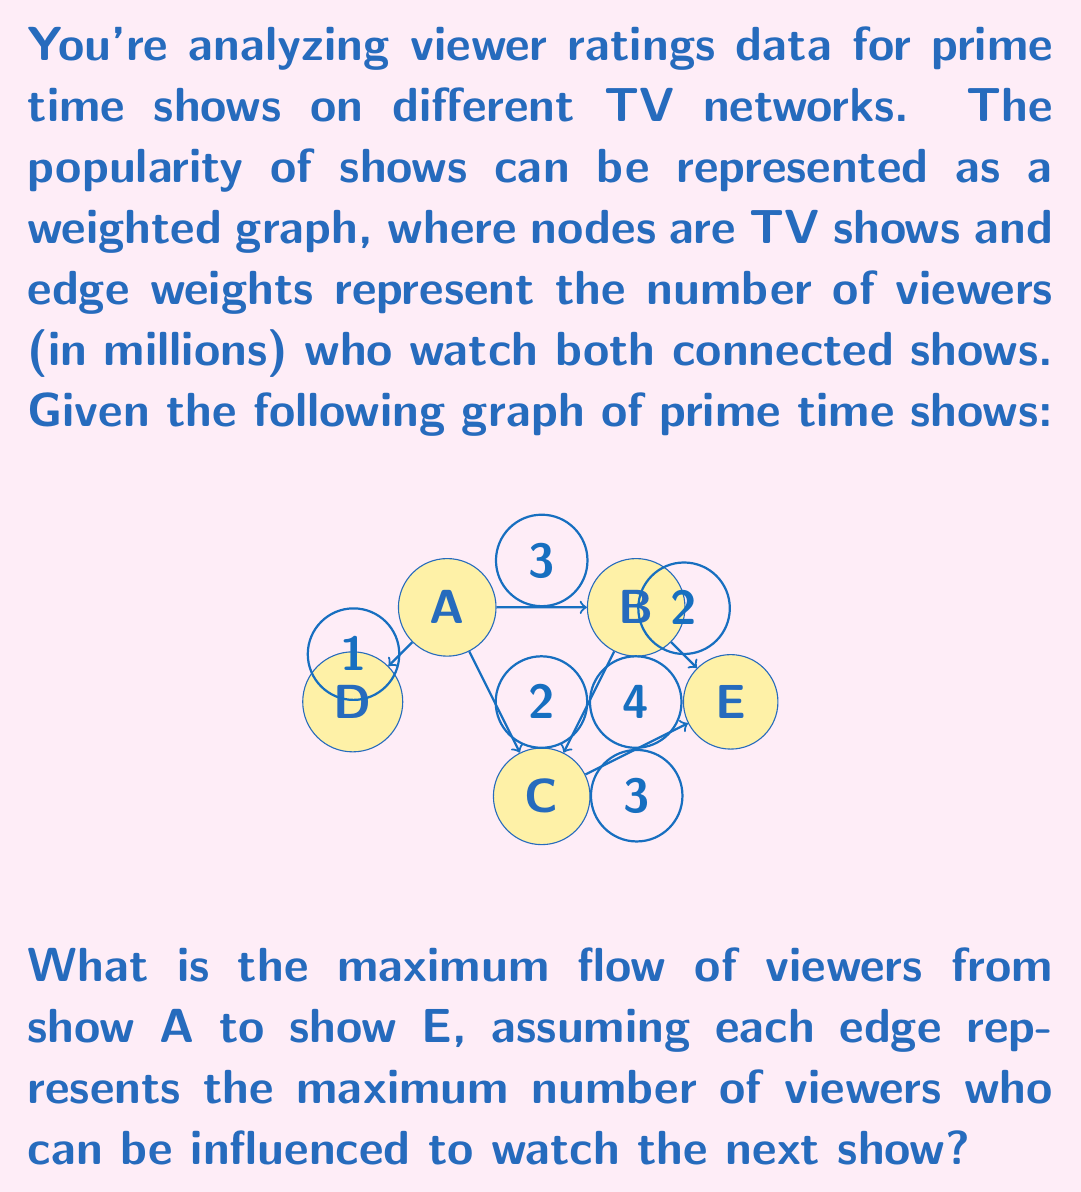Can you solve this math problem? To solve this maximum flow problem, we can use the Ford-Fulkerson algorithm. Here's a step-by-step explanation:

1) First, we need to identify all possible paths from A to E:
   Path 1: A → B → E
   Path 2: A → C → E
   Path 3: A → B → C → E

2) We'll iteratively find augmenting paths and update the residual graph:

   Iteration 1:
   - Choose path A → B → E with a flow of 2 (minimum of 3 and 2)
   - Residual capacities: A→B: 1, B→E: 0, E→B: 2

   Iteration 2:
   - Choose path A → C → E with a flow of 2 (minimum of 2 and 3)
   - Residual capacities: A→C: 0, C→E: 1, E→C: 2

   Iteration 3:
   - Choose path A → B → C → E with a flow of 1
     (A→B: 1, B→C: 4, C→E: 1)
   - Residual capacities: A→B: 0, B→C: 3, C→E: 0, E→C: 3

3) At this point, there are no more augmenting paths from A to E in the residual graph.

4) The maximum flow is the sum of all flows:
   2 (from iteration 1) + 2 (from iteration 2) + 1 (from iteration 3) = 5

Therefore, the maximum flow of viewers from show A to show E is 5 million.
Answer: 5 million viewers 